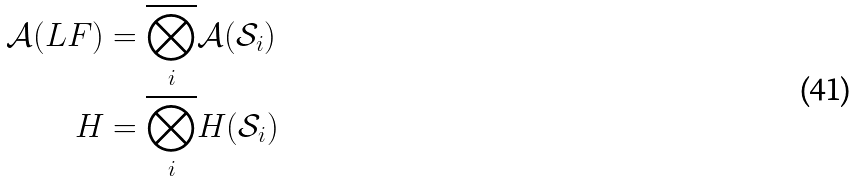Convert formula to latex. <formula><loc_0><loc_0><loc_500><loc_500>\mathcal { A } ( L F ) & = \overline { \bigotimes _ { i } } \mathcal { A } ( \mathcal { S } _ { i } ) \\ H & = \overline { \bigotimes _ { i } } H ( \mathcal { S } _ { i } )</formula> 